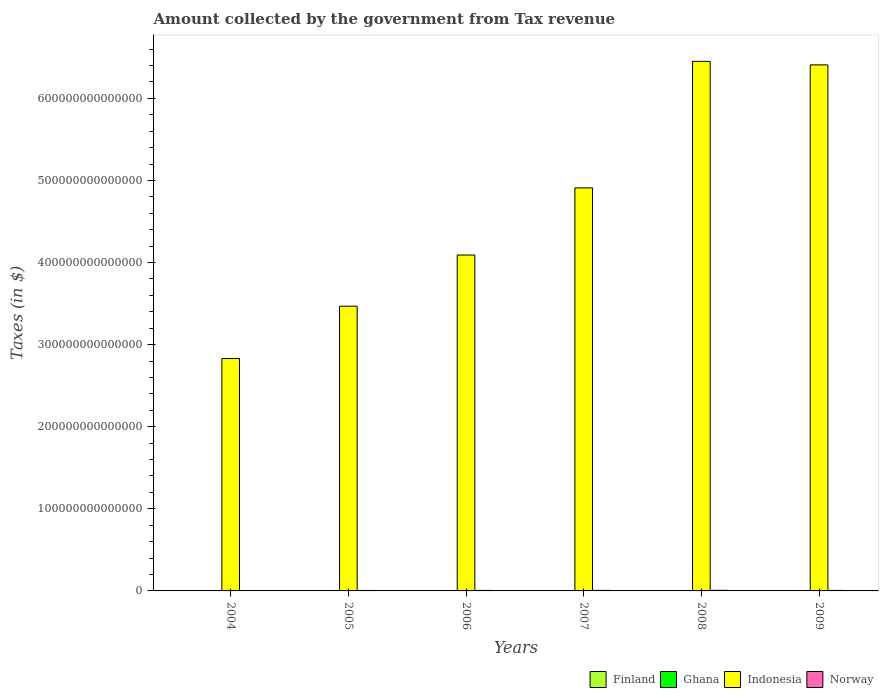How many groups of bars are there?
Make the answer very short. 6. How many bars are there on the 1st tick from the left?
Provide a short and direct response. 4. How many bars are there on the 5th tick from the right?
Give a very brief answer. 4. What is the label of the 2nd group of bars from the left?
Give a very brief answer. 2005. What is the amount collected by the government from tax revenue in Indonesia in 2008?
Your answer should be very brief. 6.45e+14. Across all years, what is the maximum amount collected by the government from tax revenue in Ghana?
Make the answer very short. 4.62e+09. Across all years, what is the minimum amount collected by the government from tax revenue in Norway?
Your answer should be compact. 4.87e+11. In which year was the amount collected by the government from tax revenue in Ghana maximum?
Make the answer very short. 2009. In which year was the amount collected by the government from tax revenue in Finland minimum?
Give a very brief answer. 2009. What is the total amount collected by the government from tax revenue in Norway in the graph?
Provide a short and direct response. 3.70e+12. What is the difference between the amount collected by the government from tax revenue in Finland in 2005 and that in 2009?
Keep it short and to the point. 1.73e+09. What is the difference between the amount collected by the government from tax revenue in Norway in 2005 and the amount collected by the government from tax revenue in Ghana in 2009?
Provide a succinct answer. 5.58e+11. What is the average amount collected by the government from tax revenue in Ghana per year?
Your answer should be very brief. 3.04e+09. In the year 2007, what is the difference between the amount collected by the government from tax revenue in Finland and amount collected by the government from tax revenue in Ghana?
Offer a very short reply. 3.57e+1. In how many years, is the amount collected by the government from tax revenue in Indonesia greater than 560000000000000 $?
Ensure brevity in your answer.  2. What is the ratio of the amount collected by the government from tax revenue in Finland in 2006 to that in 2008?
Provide a short and direct response. 0.93. Is the amount collected by the government from tax revenue in Indonesia in 2005 less than that in 2008?
Provide a short and direct response. Yes. What is the difference between the highest and the second highest amount collected by the government from tax revenue in Norway?
Offer a terse response. 6.36e+1. What is the difference between the highest and the lowest amount collected by the government from tax revenue in Finland?
Offer a very short reply. 5.55e+09. In how many years, is the amount collected by the government from tax revenue in Finland greater than the average amount collected by the government from tax revenue in Finland taken over all years?
Your response must be concise. 3. Is it the case that in every year, the sum of the amount collected by the government from tax revenue in Norway and amount collected by the government from tax revenue in Indonesia is greater than the sum of amount collected by the government from tax revenue in Finland and amount collected by the government from tax revenue in Ghana?
Ensure brevity in your answer.  Yes. What does the 2nd bar from the right in 2009 represents?
Offer a terse response. Indonesia. Is it the case that in every year, the sum of the amount collected by the government from tax revenue in Finland and amount collected by the government from tax revenue in Norway is greater than the amount collected by the government from tax revenue in Ghana?
Your answer should be very brief. Yes. What is the difference between two consecutive major ticks on the Y-axis?
Provide a succinct answer. 1.00e+14. Are the values on the major ticks of Y-axis written in scientific E-notation?
Give a very brief answer. No. Where does the legend appear in the graph?
Make the answer very short. Bottom right. How many legend labels are there?
Provide a short and direct response. 4. What is the title of the graph?
Provide a succinct answer. Amount collected by the government from Tax revenue. Does "New Caledonia" appear as one of the legend labels in the graph?
Make the answer very short. No. What is the label or title of the X-axis?
Your response must be concise. Years. What is the label or title of the Y-axis?
Offer a terse response. Taxes (in $). What is the Taxes (in $) of Finland in 2004?
Provide a short and direct response. 3.43e+1. What is the Taxes (in $) of Ghana in 2004?
Your answer should be compact. 1.74e+09. What is the Taxes (in $) of Indonesia in 2004?
Give a very brief answer. 2.83e+14. What is the Taxes (in $) of Norway in 2004?
Your answer should be very brief. 4.87e+11. What is the Taxes (in $) in Finland in 2005?
Keep it short and to the point. 3.56e+1. What is the Taxes (in $) in Ghana in 2005?
Provide a succinct answer. 2.07e+09. What is the Taxes (in $) in Indonesia in 2005?
Your answer should be very brief. 3.47e+14. What is the Taxes (in $) of Norway in 2005?
Your answer should be compact. 5.63e+11. What is the Taxes (in $) of Finland in 2006?
Give a very brief answer. 3.66e+1. What is the Taxes (in $) in Ghana in 2006?
Ensure brevity in your answer.  2.40e+09. What is the Taxes (in $) in Indonesia in 2006?
Offer a very short reply. 4.09e+14. What is the Taxes (in $) of Norway in 2006?
Offer a very short reply. 6.41e+11. What is the Taxes (in $) of Finland in 2007?
Keep it short and to the point. 3.90e+1. What is the Taxes (in $) of Ghana in 2007?
Give a very brief answer. 3.21e+09. What is the Taxes (in $) in Indonesia in 2007?
Keep it short and to the point. 4.91e+14. What is the Taxes (in $) of Norway in 2007?
Give a very brief answer. 6.60e+11. What is the Taxes (in $) in Finland in 2008?
Keep it short and to the point. 3.94e+1. What is the Taxes (in $) in Ghana in 2008?
Keep it short and to the point. 4.19e+09. What is the Taxes (in $) in Indonesia in 2008?
Keep it short and to the point. 6.45e+14. What is the Taxes (in $) in Norway in 2008?
Make the answer very short. 7.24e+11. What is the Taxes (in $) of Finland in 2009?
Offer a very short reply. 3.38e+1. What is the Taxes (in $) in Ghana in 2009?
Keep it short and to the point. 4.62e+09. What is the Taxes (in $) in Indonesia in 2009?
Provide a short and direct response. 6.41e+14. What is the Taxes (in $) in Norway in 2009?
Provide a short and direct response. 6.26e+11. Across all years, what is the maximum Taxes (in $) of Finland?
Offer a terse response. 3.94e+1. Across all years, what is the maximum Taxes (in $) of Ghana?
Your answer should be very brief. 4.62e+09. Across all years, what is the maximum Taxes (in $) of Indonesia?
Offer a very short reply. 6.45e+14. Across all years, what is the maximum Taxes (in $) in Norway?
Offer a very short reply. 7.24e+11. Across all years, what is the minimum Taxes (in $) of Finland?
Provide a short and direct response. 3.38e+1. Across all years, what is the minimum Taxes (in $) in Ghana?
Your answer should be compact. 1.74e+09. Across all years, what is the minimum Taxes (in $) of Indonesia?
Provide a short and direct response. 2.83e+14. Across all years, what is the minimum Taxes (in $) of Norway?
Offer a very short reply. 4.87e+11. What is the total Taxes (in $) in Finland in the graph?
Make the answer very short. 2.19e+11. What is the total Taxes (in $) of Ghana in the graph?
Your answer should be compact. 1.82e+1. What is the total Taxes (in $) of Indonesia in the graph?
Keep it short and to the point. 2.82e+15. What is the total Taxes (in $) in Norway in the graph?
Your answer should be very brief. 3.70e+12. What is the difference between the Taxes (in $) in Finland in 2004 and that in 2005?
Offer a very short reply. -1.22e+09. What is the difference between the Taxes (in $) of Ghana in 2004 and that in 2005?
Keep it short and to the point. -3.36e+08. What is the difference between the Taxes (in $) of Indonesia in 2004 and that in 2005?
Provide a short and direct response. -6.38e+13. What is the difference between the Taxes (in $) in Norway in 2004 and that in 2005?
Your answer should be very brief. -7.53e+1. What is the difference between the Taxes (in $) in Finland in 2004 and that in 2006?
Make the answer very short. -2.30e+09. What is the difference between the Taxes (in $) of Ghana in 2004 and that in 2006?
Keep it short and to the point. -6.58e+08. What is the difference between the Taxes (in $) of Indonesia in 2004 and that in 2006?
Make the answer very short. -1.26e+14. What is the difference between the Taxes (in $) in Norway in 2004 and that in 2006?
Your response must be concise. -1.54e+11. What is the difference between the Taxes (in $) of Finland in 2004 and that in 2007?
Offer a terse response. -4.62e+09. What is the difference between the Taxes (in $) of Ghana in 2004 and that in 2007?
Your answer should be compact. -1.48e+09. What is the difference between the Taxes (in $) of Indonesia in 2004 and that in 2007?
Offer a very short reply. -2.08e+14. What is the difference between the Taxes (in $) of Norway in 2004 and that in 2007?
Your answer should be very brief. -1.72e+11. What is the difference between the Taxes (in $) in Finland in 2004 and that in 2008?
Keep it short and to the point. -5.04e+09. What is the difference between the Taxes (in $) in Ghana in 2004 and that in 2008?
Your response must be concise. -2.46e+09. What is the difference between the Taxes (in $) of Indonesia in 2004 and that in 2008?
Your answer should be very brief. -3.62e+14. What is the difference between the Taxes (in $) in Norway in 2004 and that in 2008?
Keep it short and to the point. -2.36e+11. What is the difference between the Taxes (in $) of Finland in 2004 and that in 2009?
Make the answer very short. 5.11e+08. What is the difference between the Taxes (in $) in Ghana in 2004 and that in 2009?
Your answer should be compact. -2.88e+09. What is the difference between the Taxes (in $) in Indonesia in 2004 and that in 2009?
Provide a short and direct response. -3.58e+14. What is the difference between the Taxes (in $) in Norway in 2004 and that in 2009?
Provide a short and direct response. -1.39e+11. What is the difference between the Taxes (in $) in Finland in 2005 and that in 2006?
Your response must be concise. -1.08e+09. What is the difference between the Taxes (in $) of Ghana in 2005 and that in 2006?
Ensure brevity in your answer.  -3.22e+08. What is the difference between the Taxes (in $) in Indonesia in 2005 and that in 2006?
Your answer should be compact. -6.24e+13. What is the difference between the Taxes (in $) in Norway in 2005 and that in 2006?
Ensure brevity in your answer.  -7.84e+1. What is the difference between the Taxes (in $) of Finland in 2005 and that in 2007?
Offer a terse response. -3.40e+09. What is the difference between the Taxes (in $) in Ghana in 2005 and that in 2007?
Your answer should be very brief. -1.14e+09. What is the difference between the Taxes (in $) in Indonesia in 2005 and that in 2007?
Provide a short and direct response. -1.44e+14. What is the difference between the Taxes (in $) in Norway in 2005 and that in 2007?
Provide a succinct answer. -9.72e+1. What is the difference between the Taxes (in $) of Finland in 2005 and that in 2008?
Your response must be concise. -3.82e+09. What is the difference between the Taxes (in $) of Ghana in 2005 and that in 2008?
Ensure brevity in your answer.  -2.12e+09. What is the difference between the Taxes (in $) of Indonesia in 2005 and that in 2008?
Your answer should be compact. -2.98e+14. What is the difference between the Taxes (in $) in Norway in 2005 and that in 2008?
Provide a succinct answer. -1.61e+11. What is the difference between the Taxes (in $) of Finland in 2005 and that in 2009?
Keep it short and to the point. 1.73e+09. What is the difference between the Taxes (in $) in Ghana in 2005 and that in 2009?
Your response must be concise. -2.54e+09. What is the difference between the Taxes (in $) of Indonesia in 2005 and that in 2009?
Provide a succinct answer. -2.94e+14. What is the difference between the Taxes (in $) of Norway in 2005 and that in 2009?
Give a very brief answer. -6.37e+1. What is the difference between the Taxes (in $) in Finland in 2006 and that in 2007?
Your response must be concise. -2.32e+09. What is the difference between the Taxes (in $) in Ghana in 2006 and that in 2007?
Make the answer very short. -8.18e+08. What is the difference between the Taxes (in $) in Indonesia in 2006 and that in 2007?
Provide a short and direct response. -8.18e+13. What is the difference between the Taxes (in $) in Norway in 2006 and that in 2007?
Ensure brevity in your answer.  -1.88e+1. What is the difference between the Taxes (in $) of Finland in 2006 and that in 2008?
Give a very brief answer. -2.74e+09. What is the difference between the Taxes (in $) of Ghana in 2006 and that in 2008?
Give a very brief answer. -1.80e+09. What is the difference between the Taxes (in $) in Indonesia in 2006 and that in 2008?
Offer a terse response. -2.36e+14. What is the difference between the Taxes (in $) of Norway in 2006 and that in 2008?
Your answer should be very brief. -8.24e+1. What is the difference between the Taxes (in $) in Finland in 2006 and that in 2009?
Ensure brevity in your answer.  2.81e+09. What is the difference between the Taxes (in $) of Ghana in 2006 and that in 2009?
Provide a succinct answer. -2.22e+09. What is the difference between the Taxes (in $) of Indonesia in 2006 and that in 2009?
Your response must be concise. -2.32e+14. What is the difference between the Taxes (in $) of Norway in 2006 and that in 2009?
Give a very brief answer. 1.47e+1. What is the difference between the Taxes (in $) in Finland in 2007 and that in 2008?
Ensure brevity in your answer.  -4.18e+08. What is the difference between the Taxes (in $) in Ghana in 2007 and that in 2008?
Provide a succinct answer. -9.80e+08. What is the difference between the Taxes (in $) of Indonesia in 2007 and that in 2008?
Provide a short and direct response. -1.54e+14. What is the difference between the Taxes (in $) in Norway in 2007 and that in 2008?
Your answer should be very brief. -6.36e+1. What is the difference between the Taxes (in $) of Finland in 2007 and that in 2009?
Your response must be concise. 5.14e+09. What is the difference between the Taxes (in $) in Ghana in 2007 and that in 2009?
Provide a short and direct response. -1.40e+09. What is the difference between the Taxes (in $) in Indonesia in 2007 and that in 2009?
Offer a very short reply. -1.50e+14. What is the difference between the Taxes (in $) of Norway in 2007 and that in 2009?
Your response must be concise. 3.35e+1. What is the difference between the Taxes (in $) of Finland in 2008 and that in 2009?
Provide a succinct answer. 5.55e+09. What is the difference between the Taxes (in $) in Ghana in 2008 and that in 2009?
Offer a terse response. -4.22e+08. What is the difference between the Taxes (in $) in Indonesia in 2008 and that in 2009?
Your answer should be very brief. 4.29e+12. What is the difference between the Taxes (in $) of Norway in 2008 and that in 2009?
Ensure brevity in your answer.  9.71e+1. What is the difference between the Taxes (in $) in Finland in 2004 and the Taxes (in $) in Ghana in 2005?
Offer a terse response. 3.23e+1. What is the difference between the Taxes (in $) of Finland in 2004 and the Taxes (in $) of Indonesia in 2005?
Offer a very short reply. -3.47e+14. What is the difference between the Taxes (in $) in Finland in 2004 and the Taxes (in $) in Norway in 2005?
Give a very brief answer. -5.28e+11. What is the difference between the Taxes (in $) of Ghana in 2004 and the Taxes (in $) of Indonesia in 2005?
Provide a succinct answer. -3.47e+14. What is the difference between the Taxes (in $) in Ghana in 2004 and the Taxes (in $) in Norway in 2005?
Provide a short and direct response. -5.61e+11. What is the difference between the Taxes (in $) in Indonesia in 2004 and the Taxes (in $) in Norway in 2005?
Your answer should be compact. 2.83e+14. What is the difference between the Taxes (in $) in Finland in 2004 and the Taxes (in $) in Ghana in 2006?
Make the answer very short. 3.19e+1. What is the difference between the Taxes (in $) in Finland in 2004 and the Taxes (in $) in Indonesia in 2006?
Provide a succinct answer. -4.09e+14. What is the difference between the Taxes (in $) in Finland in 2004 and the Taxes (in $) in Norway in 2006?
Keep it short and to the point. -6.07e+11. What is the difference between the Taxes (in $) of Ghana in 2004 and the Taxes (in $) of Indonesia in 2006?
Give a very brief answer. -4.09e+14. What is the difference between the Taxes (in $) in Ghana in 2004 and the Taxes (in $) in Norway in 2006?
Your answer should be compact. -6.39e+11. What is the difference between the Taxes (in $) of Indonesia in 2004 and the Taxes (in $) of Norway in 2006?
Your response must be concise. 2.82e+14. What is the difference between the Taxes (in $) in Finland in 2004 and the Taxes (in $) in Ghana in 2007?
Your answer should be very brief. 3.11e+1. What is the difference between the Taxes (in $) in Finland in 2004 and the Taxes (in $) in Indonesia in 2007?
Give a very brief answer. -4.91e+14. What is the difference between the Taxes (in $) in Finland in 2004 and the Taxes (in $) in Norway in 2007?
Ensure brevity in your answer.  -6.26e+11. What is the difference between the Taxes (in $) in Ghana in 2004 and the Taxes (in $) in Indonesia in 2007?
Offer a very short reply. -4.91e+14. What is the difference between the Taxes (in $) of Ghana in 2004 and the Taxes (in $) of Norway in 2007?
Make the answer very short. -6.58e+11. What is the difference between the Taxes (in $) in Indonesia in 2004 and the Taxes (in $) in Norway in 2007?
Offer a very short reply. 2.82e+14. What is the difference between the Taxes (in $) of Finland in 2004 and the Taxes (in $) of Ghana in 2008?
Provide a short and direct response. 3.01e+1. What is the difference between the Taxes (in $) in Finland in 2004 and the Taxes (in $) in Indonesia in 2008?
Your response must be concise. -6.45e+14. What is the difference between the Taxes (in $) of Finland in 2004 and the Taxes (in $) of Norway in 2008?
Your answer should be compact. -6.89e+11. What is the difference between the Taxes (in $) of Ghana in 2004 and the Taxes (in $) of Indonesia in 2008?
Offer a very short reply. -6.45e+14. What is the difference between the Taxes (in $) in Ghana in 2004 and the Taxes (in $) in Norway in 2008?
Give a very brief answer. -7.22e+11. What is the difference between the Taxes (in $) in Indonesia in 2004 and the Taxes (in $) in Norway in 2008?
Provide a succinct answer. 2.82e+14. What is the difference between the Taxes (in $) in Finland in 2004 and the Taxes (in $) in Ghana in 2009?
Make the answer very short. 2.97e+1. What is the difference between the Taxes (in $) in Finland in 2004 and the Taxes (in $) in Indonesia in 2009?
Offer a very short reply. -6.41e+14. What is the difference between the Taxes (in $) in Finland in 2004 and the Taxes (in $) in Norway in 2009?
Your answer should be very brief. -5.92e+11. What is the difference between the Taxes (in $) in Ghana in 2004 and the Taxes (in $) in Indonesia in 2009?
Your answer should be compact. -6.41e+14. What is the difference between the Taxes (in $) of Ghana in 2004 and the Taxes (in $) of Norway in 2009?
Offer a very short reply. -6.25e+11. What is the difference between the Taxes (in $) in Indonesia in 2004 and the Taxes (in $) in Norway in 2009?
Your answer should be compact. 2.82e+14. What is the difference between the Taxes (in $) in Finland in 2005 and the Taxes (in $) in Ghana in 2006?
Keep it short and to the point. 3.32e+1. What is the difference between the Taxes (in $) in Finland in 2005 and the Taxes (in $) in Indonesia in 2006?
Your answer should be compact. -4.09e+14. What is the difference between the Taxes (in $) of Finland in 2005 and the Taxes (in $) of Norway in 2006?
Keep it short and to the point. -6.06e+11. What is the difference between the Taxes (in $) in Ghana in 2005 and the Taxes (in $) in Indonesia in 2006?
Provide a succinct answer. -4.09e+14. What is the difference between the Taxes (in $) of Ghana in 2005 and the Taxes (in $) of Norway in 2006?
Your answer should be very brief. -6.39e+11. What is the difference between the Taxes (in $) of Indonesia in 2005 and the Taxes (in $) of Norway in 2006?
Ensure brevity in your answer.  3.46e+14. What is the difference between the Taxes (in $) in Finland in 2005 and the Taxes (in $) in Ghana in 2007?
Make the answer very short. 3.23e+1. What is the difference between the Taxes (in $) in Finland in 2005 and the Taxes (in $) in Indonesia in 2007?
Provide a short and direct response. -4.91e+14. What is the difference between the Taxes (in $) in Finland in 2005 and the Taxes (in $) in Norway in 2007?
Offer a very short reply. -6.24e+11. What is the difference between the Taxes (in $) of Ghana in 2005 and the Taxes (in $) of Indonesia in 2007?
Provide a short and direct response. -4.91e+14. What is the difference between the Taxes (in $) in Ghana in 2005 and the Taxes (in $) in Norway in 2007?
Make the answer very short. -6.58e+11. What is the difference between the Taxes (in $) in Indonesia in 2005 and the Taxes (in $) in Norway in 2007?
Offer a very short reply. 3.46e+14. What is the difference between the Taxes (in $) of Finland in 2005 and the Taxes (in $) of Ghana in 2008?
Provide a succinct answer. 3.14e+1. What is the difference between the Taxes (in $) in Finland in 2005 and the Taxes (in $) in Indonesia in 2008?
Provide a short and direct response. -6.45e+14. What is the difference between the Taxes (in $) in Finland in 2005 and the Taxes (in $) in Norway in 2008?
Give a very brief answer. -6.88e+11. What is the difference between the Taxes (in $) of Ghana in 2005 and the Taxes (in $) of Indonesia in 2008?
Make the answer very short. -6.45e+14. What is the difference between the Taxes (in $) of Ghana in 2005 and the Taxes (in $) of Norway in 2008?
Your response must be concise. -7.21e+11. What is the difference between the Taxes (in $) of Indonesia in 2005 and the Taxes (in $) of Norway in 2008?
Ensure brevity in your answer.  3.46e+14. What is the difference between the Taxes (in $) in Finland in 2005 and the Taxes (in $) in Ghana in 2009?
Offer a very short reply. 3.09e+1. What is the difference between the Taxes (in $) in Finland in 2005 and the Taxes (in $) in Indonesia in 2009?
Offer a terse response. -6.41e+14. What is the difference between the Taxes (in $) in Finland in 2005 and the Taxes (in $) in Norway in 2009?
Your answer should be very brief. -5.91e+11. What is the difference between the Taxes (in $) of Ghana in 2005 and the Taxes (in $) of Indonesia in 2009?
Make the answer very short. -6.41e+14. What is the difference between the Taxes (in $) of Ghana in 2005 and the Taxes (in $) of Norway in 2009?
Provide a succinct answer. -6.24e+11. What is the difference between the Taxes (in $) in Indonesia in 2005 and the Taxes (in $) in Norway in 2009?
Give a very brief answer. 3.46e+14. What is the difference between the Taxes (in $) of Finland in 2006 and the Taxes (in $) of Ghana in 2007?
Your answer should be very brief. 3.34e+1. What is the difference between the Taxes (in $) in Finland in 2006 and the Taxes (in $) in Indonesia in 2007?
Provide a succinct answer. -4.91e+14. What is the difference between the Taxes (in $) in Finland in 2006 and the Taxes (in $) in Norway in 2007?
Your response must be concise. -6.23e+11. What is the difference between the Taxes (in $) in Ghana in 2006 and the Taxes (in $) in Indonesia in 2007?
Offer a terse response. -4.91e+14. What is the difference between the Taxes (in $) of Ghana in 2006 and the Taxes (in $) of Norway in 2007?
Provide a succinct answer. -6.57e+11. What is the difference between the Taxes (in $) in Indonesia in 2006 and the Taxes (in $) in Norway in 2007?
Provide a short and direct response. 4.09e+14. What is the difference between the Taxes (in $) in Finland in 2006 and the Taxes (in $) in Ghana in 2008?
Make the answer very short. 3.24e+1. What is the difference between the Taxes (in $) of Finland in 2006 and the Taxes (in $) of Indonesia in 2008?
Make the answer very short. -6.45e+14. What is the difference between the Taxes (in $) in Finland in 2006 and the Taxes (in $) in Norway in 2008?
Ensure brevity in your answer.  -6.87e+11. What is the difference between the Taxes (in $) in Ghana in 2006 and the Taxes (in $) in Indonesia in 2008?
Provide a succinct answer. -6.45e+14. What is the difference between the Taxes (in $) of Ghana in 2006 and the Taxes (in $) of Norway in 2008?
Provide a short and direct response. -7.21e+11. What is the difference between the Taxes (in $) in Indonesia in 2006 and the Taxes (in $) in Norway in 2008?
Offer a terse response. 4.08e+14. What is the difference between the Taxes (in $) in Finland in 2006 and the Taxes (in $) in Ghana in 2009?
Your response must be concise. 3.20e+1. What is the difference between the Taxes (in $) of Finland in 2006 and the Taxes (in $) of Indonesia in 2009?
Provide a succinct answer. -6.41e+14. What is the difference between the Taxes (in $) of Finland in 2006 and the Taxes (in $) of Norway in 2009?
Offer a very short reply. -5.90e+11. What is the difference between the Taxes (in $) of Ghana in 2006 and the Taxes (in $) of Indonesia in 2009?
Offer a very short reply. -6.41e+14. What is the difference between the Taxes (in $) in Ghana in 2006 and the Taxes (in $) in Norway in 2009?
Give a very brief answer. -6.24e+11. What is the difference between the Taxes (in $) of Indonesia in 2006 and the Taxes (in $) of Norway in 2009?
Offer a terse response. 4.09e+14. What is the difference between the Taxes (in $) of Finland in 2007 and the Taxes (in $) of Ghana in 2008?
Provide a succinct answer. 3.48e+1. What is the difference between the Taxes (in $) of Finland in 2007 and the Taxes (in $) of Indonesia in 2008?
Your response must be concise. -6.45e+14. What is the difference between the Taxes (in $) of Finland in 2007 and the Taxes (in $) of Norway in 2008?
Ensure brevity in your answer.  -6.85e+11. What is the difference between the Taxes (in $) in Ghana in 2007 and the Taxes (in $) in Indonesia in 2008?
Keep it short and to the point. -6.45e+14. What is the difference between the Taxes (in $) in Ghana in 2007 and the Taxes (in $) in Norway in 2008?
Your answer should be compact. -7.20e+11. What is the difference between the Taxes (in $) of Indonesia in 2007 and the Taxes (in $) of Norway in 2008?
Provide a succinct answer. 4.90e+14. What is the difference between the Taxes (in $) of Finland in 2007 and the Taxes (in $) of Ghana in 2009?
Provide a succinct answer. 3.43e+1. What is the difference between the Taxes (in $) of Finland in 2007 and the Taxes (in $) of Indonesia in 2009?
Offer a terse response. -6.41e+14. What is the difference between the Taxes (in $) in Finland in 2007 and the Taxes (in $) in Norway in 2009?
Ensure brevity in your answer.  -5.87e+11. What is the difference between the Taxes (in $) of Ghana in 2007 and the Taxes (in $) of Indonesia in 2009?
Provide a short and direct response. -6.41e+14. What is the difference between the Taxes (in $) in Ghana in 2007 and the Taxes (in $) in Norway in 2009?
Give a very brief answer. -6.23e+11. What is the difference between the Taxes (in $) of Indonesia in 2007 and the Taxes (in $) of Norway in 2009?
Your answer should be very brief. 4.90e+14. What is the difference between the Taxes (in $) in Finland in 2008 and the Taxes (in $) in Ghana in 2009?
Keep it short and to the point. 3.48e+1. What is the difference between the Taxes (in $) in Finland in 2008 and the Taxes (in $) in Indonesia in 2009?
Offer a very short reply. -6.41e+14. What is the difference between the Taxes (in $) of Finland in 2008 and the Taxes (in $) of Norway in 2009?
Your answer should be compact. -5.87e+11. What is the difference between the Taxes (in $) in Ghana in 2008 and the Taxes (in $) in Indonesia in 2009?
Offer a very short reply. -6.41e+14. What is the difference between the Taxes (in $) in Ghana in 2008 and the Taxes (in $) in Norway in 2009?
Provide a short and direct response. -6.22e+11. What is the difference between the Taxes (in $) of Indonesia in 2008 and the Taxes (in $) of Norway in 2009?
Ensure brevity in your answer.  6.44e+14. What is the average Taxes (in $) of Finland per year?
Provide a short and direct response. 3.64e+1. What is the average Taxes (in $) of Ghana per year?
Your answer should be very brief. 3.04e+09. What is the average Taxes (in $) of Indonesia per year?
Keep it short and to the point. 4.69e+14. What is the average Taxes (in $) of Norway per year?
Make the answer very short. 6.17e+11. In the year 2004, what is the difference between the Taxes (in $) of Finland and Taxes (in $) of Ghana?
Your answer should be very brief. 3.26e+1. In the year 2004, what is the difference between the Taxes (in $) in Finland and Taxes (in $) in Indonesia?
Your answer should be very brief. -2.83e+14. In the year 2004, what is the difference between the Taxes (in $) in Finland and Taxes (in $) in Norway?
Provide a succinct answer. -4.53e+11. In the year 2004, what is the difference between the Taxes (in $) in Ghana and Taxes (in $) in Indonesia?
Offer a very short reply. -2.83e+14. In the year 2004, what is the difference between the Taxes (in $) in Ghana and Taxes (in $) in Norway?
Your answer should be compact. -4.86e+11. In the year 2004, what is the difference between the Taxes (in $) in Indonesia and Taxes (in $) in Norway?
Ensure brevity in your answer.  2.83e+14. In the year 2005, what is the difference between the Taxes (in $) in Finland and Taxes (in $) in Ghana?
Your answer should be very brief. 3.35e+1. In the year 2005, what is the difference between the Taxes (in $) in Finland and Taxes (in $) in Indonesia?
Ensure brevity in your answer.  -3.47e+14. In the year 2005, what is the difference between the Taxes (in $) in Finland and Taxes (in $) in Norway?
Give a very brief answer. -5.27e+11. In the year 2005, what is the difference between the Taxes (in $) in Ghana and Taxes (in $) in Indonesia?
Give a very brief answer. -3.47e+14. In the year 2005, what is the difference between the Taxes (in $) in Ghana and Taxes (in $) in Norway?
Offer a very short reply. -5.61e+11. In the year 2005, what is the difference between the Taxes (in $) in Indonesia and Taxes (in $) in Norway?
Give a very brief answer. 3.46e+14. In the year 2006, what is the difference between the Taxes (in $) in Finland and Taxes (in $) in Ghana?
Provide a short and direct response. 3.42e+1. In the year 2006, what is the difference between the Taxes (in $) in Finland and Taxes (in $) in Indonesia?
Keep it short and to the point. -4.09e+14. In the year 2006, what is the difference between the Taxes (in $) in Finland and Taxes (in $) in Norway?
Make the answer very short. -6.04e+11. In the year 2006, what is the difference between the Taxes (in $) of Ghana and Taxes (in $) of Indonesia?
Your response must be concise. -4.09e+14. In the year 2006, what is the difference between the Taxes (in $) in Ghana and Taxes (in $) in Norway?
Your response must be concise. -6.39e+11. In the year 2006, what is the difference between the Taxes (in $) of Indonesia and Taxes (in $) of Norway?
Provide a short and direct response. 4.09e+14. In the year 2007, what is the difference between the Taxes (in $) in Finland and Taxes (in $) in Ghana?
Offer a terse response. 3.57e+1. In the year 2007, what is the difference between the Taxes (in $) in Finland and Taxes (in $) in Indonesia?
Keep it short and to the point. -4.91e+14. In the year 2007, what is the difference between the Taxes (in $) in Finland and Taxes (in $) in Norway?
Provide a short and direct response. -6.21e+11. In the year 2007, what is the difference between the Taxes (in $) of Ghana and Taxes (in $) of Indonesia?
Provide a short and direct response. -4.91e+14. In the year 2007, what is the difference between the Taxes (in $) of Ghana and Taxes (in $) of Norway?
Give a very brief answer. -6.57e+11. In the year 2007, what is the difference between the Taxes (in $) in Indonesia and Taxes (in $) in Norway?
Offer a very short reply. 4.90e+14. In the year 2008, what is the difference between the Taxes (in $) in Finland and Taxes (in $) in Ghana?
Give a very brief answer. 3.52e+1. In the year 2008, what is the difference between the Taxes (in $) in Finland and Taxes (in $) in Indonesia?
Ensure brevity in your answer.  -6.45e+14. In the year 2008, what is the difference between the Taxes (in $) of Finland and Taxes (in $) of Norway?
Your answer should be compact. -6.84e+11. In the year 2008, what is the difference between the Taxes (in $) in Ghana and Taxes (in $) in Indonesia?
Provide a short and direct response. -6.45e+14. In the year 2008, what is the difference between the Taxes (in $) in Ghana and Taxes (in $) in Norway?
Your answer should be very brief. -7.19e+11. In the year 2008, what is the difference between the Taxes (in $) in Indonesia and Taxes (in $) in Norway?
Your response must be concise. 6.44e+14. In the year 2009, what is the difference between the Taxes (in $) of Finland and Taxes (in $) of Ghana?
Make the answer very short. 2.92e+1. In the year 2009, what is the difference between the Taxes (in $) of Finland and Taxes (in $) of Indonesia?
Make the answer very short. -6.41e+14. In the year 2009, what is the difference between the Taxes (in $) of Finland and Taxes (in $) of Norway?
Provide a succinct answer. -5.93e+11. In the year 2009, what is the difference between the Taxes (in $) of Ghana and Taxes (in $) of Indonesia?
Give a very brief answer. -6.41e+14. In the year 2009, what is the difference between the Taxes (in $) of Ghana and Taxes (in $) of Norway?
Provide a succinct answer. -6.22e+11. In the year 2009, what is the difference between the Taxes (in $) in Indonesia and Taxes (in $) in Norway?
Give a very brief answer. 6.40e+14. What is the ratio of the Taxes (in $) of Finland in 2004 to that in 2005?
Offer a terse response. 0.97. What is the ratio of the Taxes (in $) in Ghana in 2004 to that in 2005?
Give a very brief answer. 0.84. What is the ratio of the Taxes (in $) in Indonesia in 2004 to that in 2005?
Ensure brevity in your answer.  0.82. What is the ratio of the Taxes (in $) of Norway in 2004 to that in 2005?
Offer a very short reply. 0.87. What is the ratio of the Taxes (in $) in Finland in 2004 to that in 2006?
Ensure brevity in your answer.  0.94. What is the ratio of the Taxes (in $) in Ghana in 2004 to that in 2006?
Your answer should be very brief. 0.73. What is the ratio of the Taxes (in $) in Indonesia in 2004 to that in 2006?
Keep it short and to the point. 0.69. What is the ratio of the Taxes (in $) in Norway in 2004 to that in 2006?
Make the answer very short. 0.76. What is the ratio of the Taxes (in $) in Finland in 2004 to that in 2007?
Make the answer very short. 0.88. What is the ratio of the Taxes (in $) of Ghana in 2004 to that in 2007?
Offer a very short reply. 0.54. What is the ratio of the Taxes (in $) of Indonesia in 2004 to that in 2007?
Provide a succinct answer. 0.58. What is the ratio of the Taxes (in $) of Norway in 2004 to that in 2007?
Keep it short and to the point. 0.74. What is the ratio of the Taxes (in $) in Finland in 2004 to that in 2008?
Provide a succinct answer. 0.87. What is the ratio of the Taxes (in $) in Ghana in 2004 to that in 2008?
Give a very brief answer. 0.41. What is the ratio of the Taxes (in $) of Indonesia in 2004 to that in 2008?
Make the answer very short. 0.44. What is the ratio of the Taxes (in $) of Norway in 2004 to that in 2008?
Keep it short and to the point. 0.67. What is the ratio of the Taxes (in $) of Finland in 2004 to that in 2009?
Offer a terse response. 1.02. What is the ratio of the Taxes (in $) in Ghana in 2004 to that in 2009?
Provide a short and direct response. 0.38. What is the ratio of the Taxes (in $) in Indonesia in 2004 to that in 2009?
Ensure brevity in your answer.  0.44. What is the ratio of the Taxes (in $) of Norway in 2004 to that in 2009?
Make the answer very short. 0.78. What is the ratio of the Taxes (in $) of Finland in 2005 to that in 2006?
Ensure brevity in your answer.  0.97. What is the ratio of the Taxes (in $) of Ghana in 2005 to that in 2006?
Make the answer very short. 0.87. What is the ratio of the Taxes (in $) of Indonesia in 2005 to that in 2006?
Your response must be concise. 0.85. What is the ratio of the Taxes (in $) of Norway in 2005 to that in 2006?
Give a very brief answer. 0.88. What is the ratio of the Taxes (in $) in Finland in 2005 to that in 2007?
Offer a very short reply. 0.91. What is the ratio of the Taxes (in $) of Ghana in 2005 to that in 2007?
Give a very brief answer. 0.65. What is the ratio of the Taxes (in $) in Indonesia in 2005 to that in 2007?
Give a very brief answer. 0.71. What is the ratio of the Taxes (in $) of Norway in 2005 to that in 2007?
Give a very brief answer. 0.85. What is the ratio of the Taxes (in $) of Finland in 2005 to that in 2008?
Ensure brevity in your answer.  0.9. What is the ratio of the Taxes (in $) of Ghana in 2005 to that in 2008?
Provide a short and direct response. 0.49. What is the ratio of the Taxes (in $) of Indonesia in 2005 to that in 2008?
Offer a terse response. 0.54. What is the ratio of the Taxes (in $) in Norway in 2005 to that in 2008?
Provide a succinct answer. 0.78. What is the ratio of the Taxes (in $) of Finland in 2005 to that in 2009?
Give a very brief answer. 1.05. What is the ratio of the Taxes (in $) of Ghana in 2005 to that in 2009?
Make the answer very short. 0.45. What is the ratio of the Taxes (in $) of Indonesia in 2005 to that in 2009?
Give a very brief answer. 0.54. What is the ratio of the Taxes (in $) of Norway in 2005 to that in 2009?
Offer a very short reply. 0.9. What is the ratio of the Taxes (in $) in Finland in 2006 to that in 2007?
Your response must be concise. 0.94. What is the ratio of the Taxes (in $) in Ghana in 2006 to that in 2007?
Give a very brief answer. 0.75. What is the ratio of the Taxes (in $) in Indonesia in 2006 to that in 2007?
Provide a succinct answer. 0.83. What is the ratio of the Taxes (in $) in Norway in 2006 to that in 2007?
Provide a short and direct response. 0.97. What is the ratio of the Taxes (in $) of Finland in 2006 to that in 2008?
Give a very brief answer. 0.93. What is the ratio of the Taxes (in $) in Ghana in 2006 to that in 2008?
Your answer should be very brief. 0.57. What is the ratio of the Taxes (in $) of Indonesia in 2006 to that in 2008?
Your response must be concise. 0.63. What is the ratio of the Taxes (in $) in Norway in 2006 to that in 2008?
Keep it short and to the point. 0.89. What is the ratio of the Taxes (in $) of Finland in 2006 to that in 2009?
Your response must be concise. 1.08. What is the ratio of the Taxes (in $) in Ghana in 2006 to that in 2009?
Keep it short and to the point. 0.52. What is the ratio of the Taxes (in $) of Indonesia in 2006 to that in 2009?
Your response must be concise. 0.64. What is the ratio of the Taxes (in $) of Norway in 2006 to that in 2009?
Keep it short and to the point. 1.02. What is the ratio of the Taxes (in $) in Finland in 2007 to that in 2008?
Your response must be concise. 0.99. What is the ratio of the Taxes (in $) in Ghana in 2007 to that in 2008?
Your response must be concise. 0.77. What is the ratio of the Taxes (in $) of Indonesia in 2007 to that in 2008?
Provide a short and direct response. 0.76. What is the ratio of the Taxes (in $) of Norway in 2007 to that in 2008?
Provide a short and direct response. 0.91. What is the ratio of the Taxes (in $) in Finland in 2007 to that in 2009?
Your answer should be compact. 1.15. What is the ratio of the Taxes (in $) of Ghana in 2007 to that in 2009?
Ensure brevity in your answer.  0.7. What is the ratio of the Taxes (in $) in Indonesia in 2007 to that in 2009?
Make the answer very short. 0.77. What is the ratio of the Taxes (in $) of Norway in 2007 to that in 2009?
Your response must be concise. 1.05. What is the ratio of the Taxes (in $) in Finland in 2008 to that in 2009?
Offer a very short reply. 1.16. What is the ratio of the Taxes (in $) of Ghana in 2008 to that in 2009?
Offer a very short reply. 0.91. What is the ratio of the Taxes (in $) of Norway in 2008 to that in 2009?
Your answer should be compact. 1.16. What is the difference between the highest and the second highest Taxes (in $) in Finland?
Make the answer very short. 4.18e+08. What is the difference between the highest and the second highest Taxes (in $) in Ghana?
Your answer should be very brief. 4.22e+08. What is the difference between the highest and the second highest Taxes (in $) of Indonesia?
Offer a very short reply. 4.29e+12. What is the difference between the highest and the second highest Taxes (in $) in Norway?
Provide a succinct answer. 6.36e+1. What is the difference between the highest and the lowest Taxes (in $) in Finland?
Provide a short and direct response. 5.55e+09. What is the difference between the highest and the lowest Taxes (in $) in Ghana?
Provide a short and direct response. 2.88e+09. What is the difference between the highest and the lowest Taxes (in $) in Indonesia?
Provide a short and direct response. 3.62e+14. What is the difference between the highest and the lowest Taxes (in $) of Norway?
Your response must be concise. 2.36e+11. 